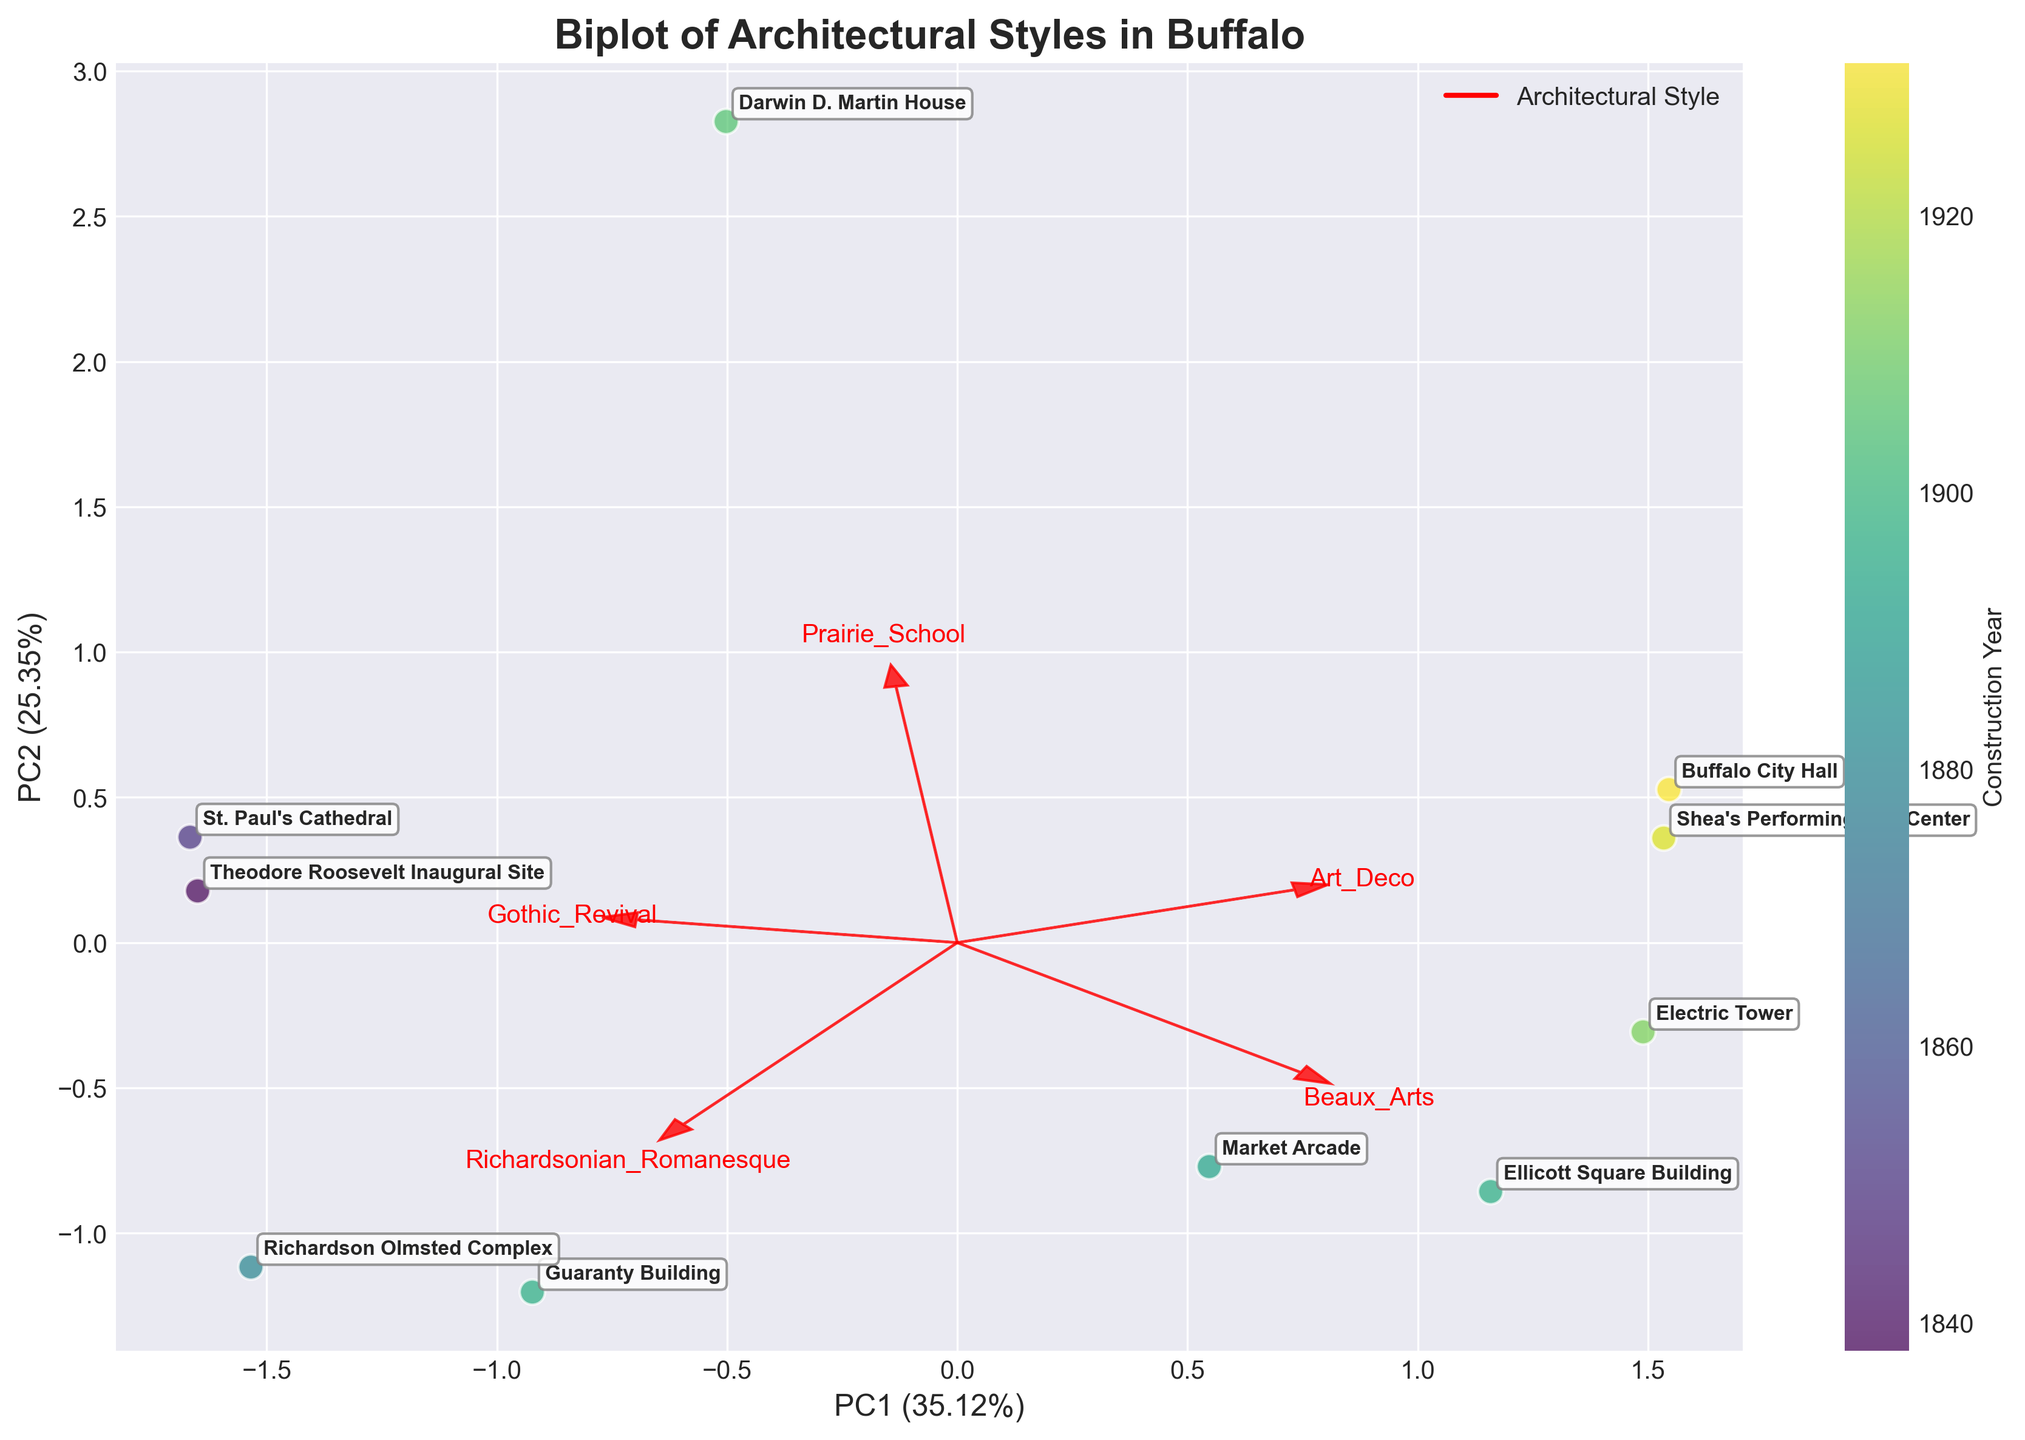How many architectural styles are featured in the biplot? Examine the plot and look for the names of architectural styles labeled on the axes.
Answer: Five Which building is represented by the point farthest to the right on the plot? Find the data point that is farthest to the right along the horizontal axis and refer to its label.
Answer: Electric Tower What is the approximate construction year of the building that is strongly associated with Art Deco style? Identify the points located near the arrow labeled "Art Deco" and refer to the color gradient to estimate the construction year.
Answer: 1931 How are Gothic Revival and Richardsonian Romanesque styles related based on the plot? Observe the angles between the arrows for Gothic Revival and Richardsonian Romanesque. If the arrows are close, the styles are positively correlated; if opposite, they are negatively correlated.
Answer: Weakly correlated Which building shows the highest association with the Prairie School style? Look for the point closest to the end of the arrow labeled "Prairie School" and refer to its label.
Answer: Darwin D. Martin House How much of the variance in the data is explained by the first principal component (PC1)? Look at the x-axis label to find the percentage of variance explained by PC1.
Answer: 56% Compare the construction years of the Guaranty Building and the Richardson Olmsted Complex. Which is older? Find the points representing these buildings, use their color codes on the color bar, then compare the years.
Answer: Richardson Olmsted Complex What is the relationship between Beaux Arts and Art Deco styles? Observe the plot and note the angles between the arrows for Beaux Arts and Art Deco. Are they pointing in similar or opposite directions?
Answer: Weakly correlated What is the most commonly represented architectural style in the biplot? Count the number of arrows representing different architectural styles and identify the one with the most labels.
Answer: Beaux Arts Which building is both associated with Richardsonian Romanesque style and was constructed around 1880? Find the point nearest the Richardsonian Romanesque arrow and cross-check its color with the nearest year on the color bar.
Answer: Richardson Olmsted Complex 